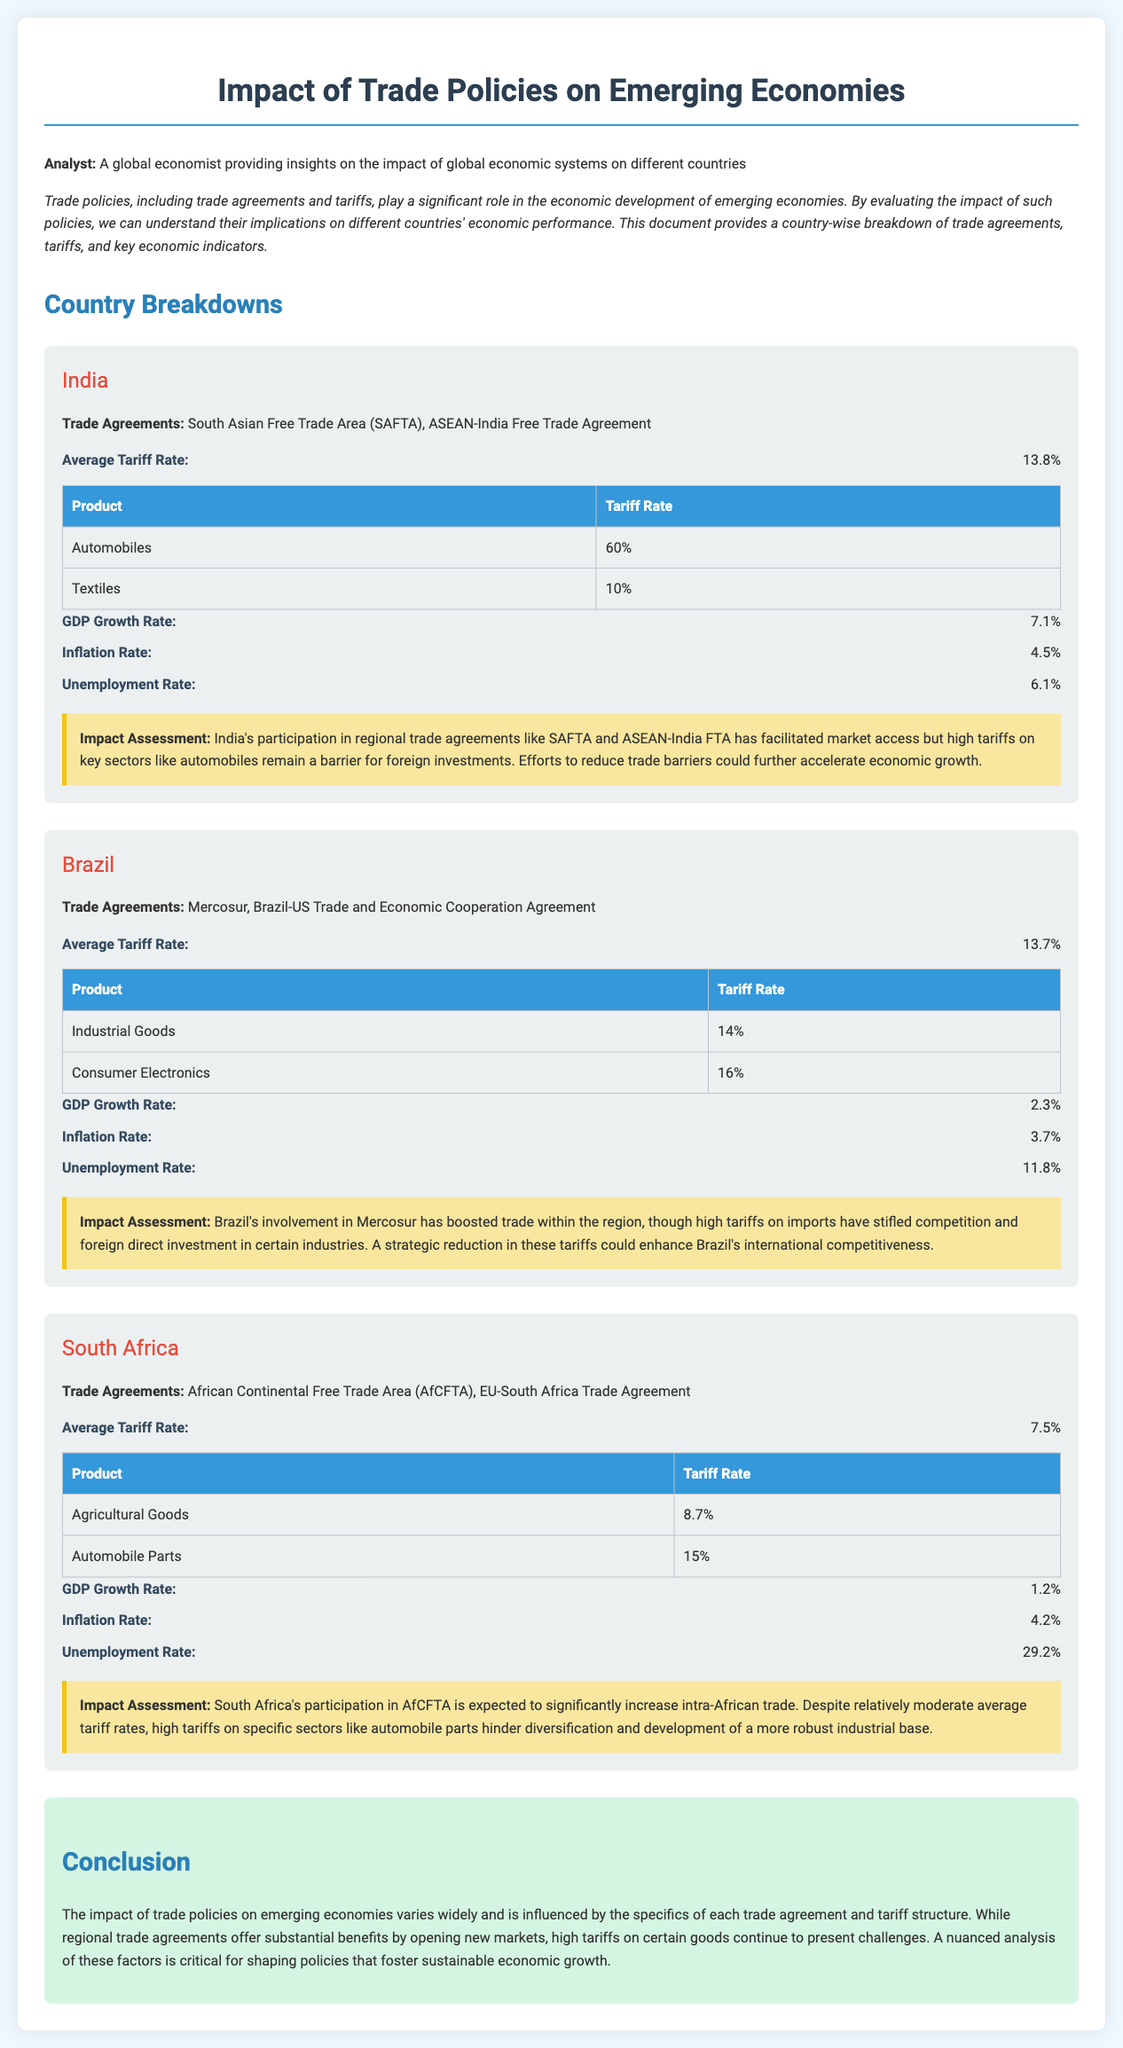what is the average tariff rate in India? The average tariff rate for India is clearly stated in the document as 13.8%.
Answer: 13.8% which trade agreements is Brazil a part of? The document lists the specific trade agreements that Brazil is a part of, which are Mercosur and Brazil-US Trade and Economic Cooperation Agreement.
Answer: Mercosur, Brazil-US Trade and Economic Cooperation Agreement what is the GDP growth rate for South Africa? The GDP growth rate is given in the section for South Africa, which states that it is 1.2%.
Answer: 1.2% what impact do high tariffs on automobile parts have in South Africa? The document makes it clear that high tariffs on specific sectors like automobile parts hinder diversification and the development of a more robust industrial base.
Answer: Hinder diversification and industrial base development what could accelerate economic growth in India? The document suggests that reducing trade barriers could accelerate economic growth for India.
Answer: Reducing trade barriers what is the unemployment rate in Brazil? The unemployment rate for Brazil is explicitly mentioned as 11.8% in the evaluation.
Answer: 11.8% how does Brazil's average tariff rate compare to India's? By comparing the average tariff rates stated in the document, Brazil's average tariff rate of 13.7% is slightly lower than India's 13.8%.
Answer: Brazil's 13.7% is lower than India's 13.8% what is the significance of trade policies on emerging economies? The document highlights the overall significance of trade policies as they play a significant role in the economic development of emerging economies.
Answer: Significant role in economic development 